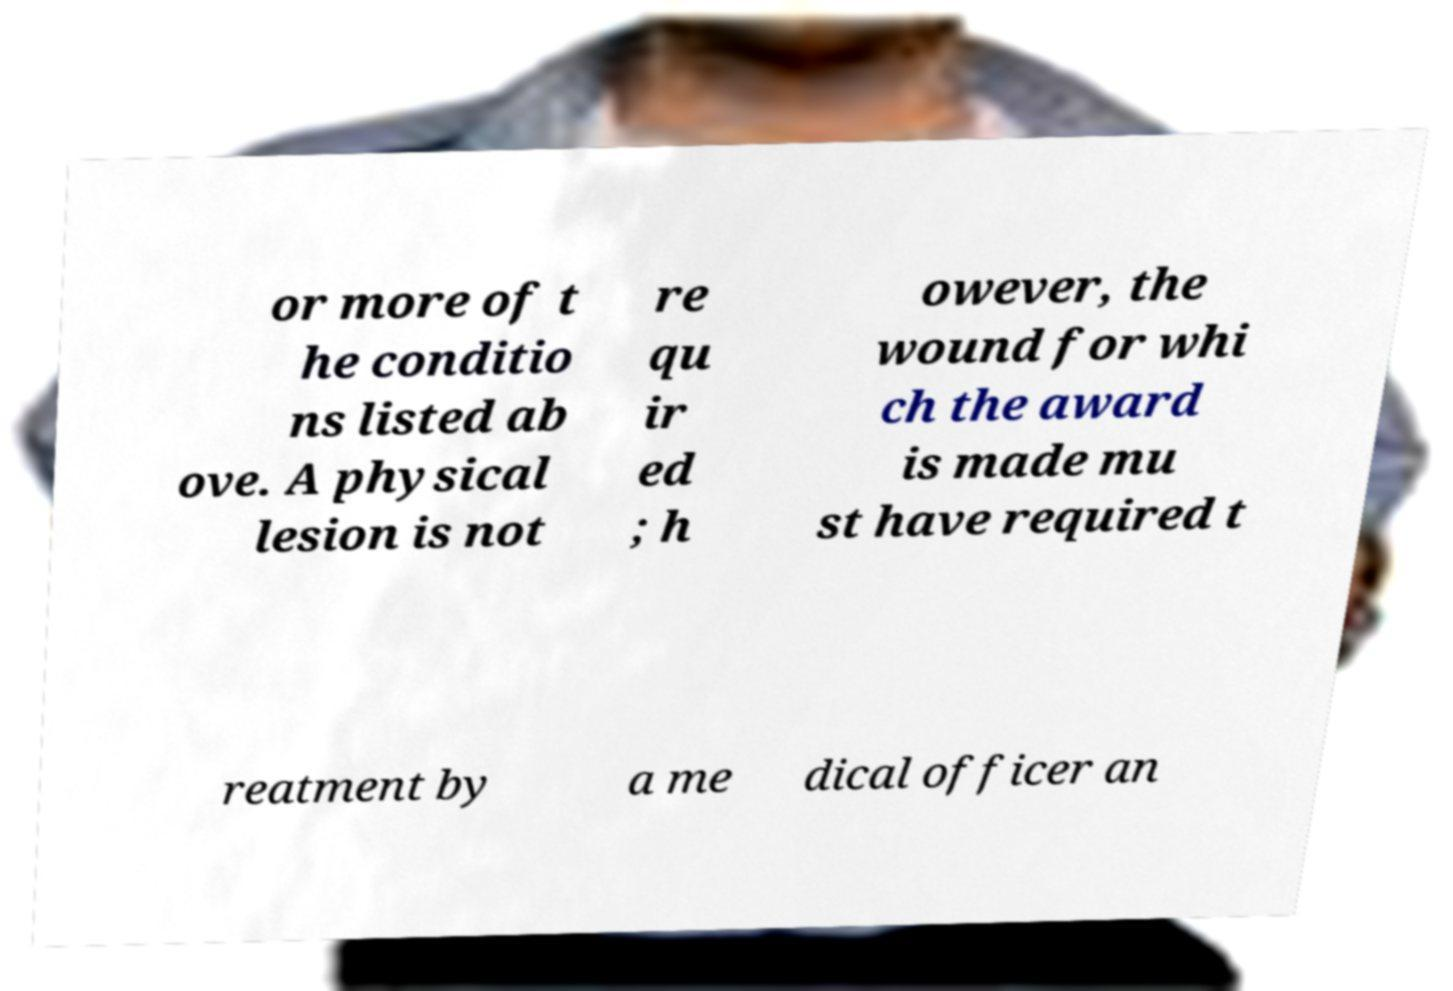Can you read and provide the text displayed in the image?This photo seems to have some interesting text. Can you extract and type it out for me? or more of t he conditio ns listed ab ove. A physical lesion is not re qu ir ed ; h owever, the wound for whi ch the award is made mu st have required t reatment by a me dical officer an 